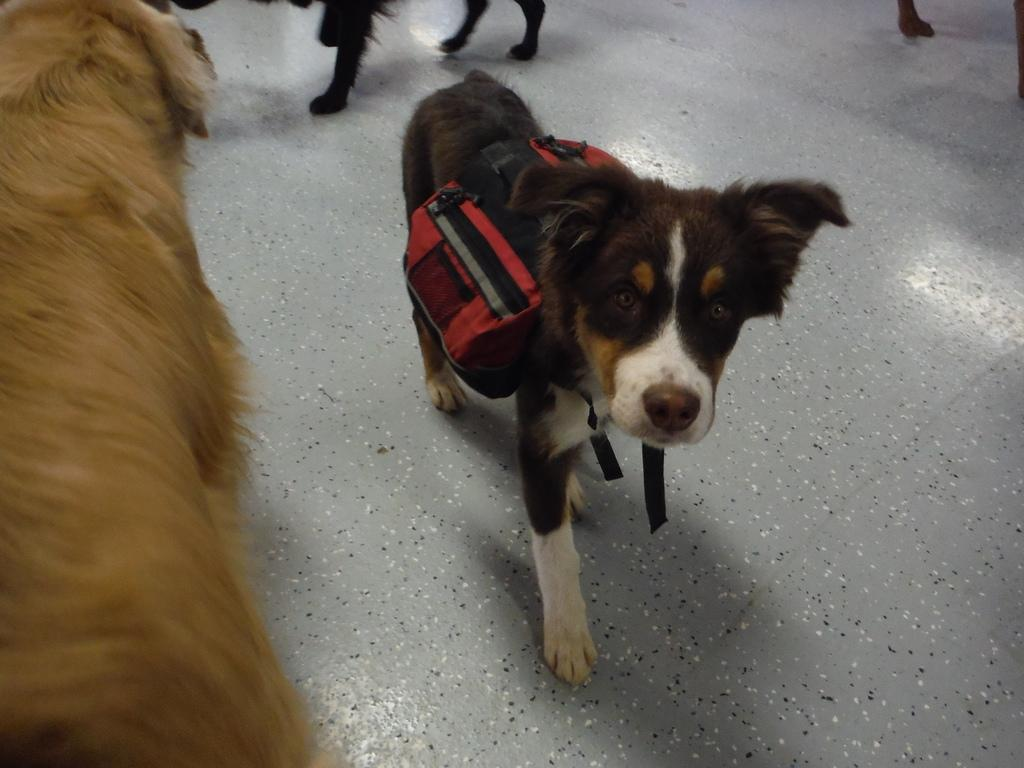What type of animals are present in the image? There are dogs in the image. Where are the dogs located in the image? The dogs are standing on the floor. How many kittens are sitting on the dogs in the image? There are no kittens present in the image; it features dogs standing on the floor. 